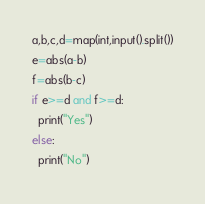Convert code to text. <code><loc_0><loc_0><loc_500><loc_500><_Python_>a,b,c,d=map(int,input().split())
e=abs(a-b)
f=abs(b-c)
if e>=d and f>=d:
  print("Yes")
else:
  print("No")</code> 